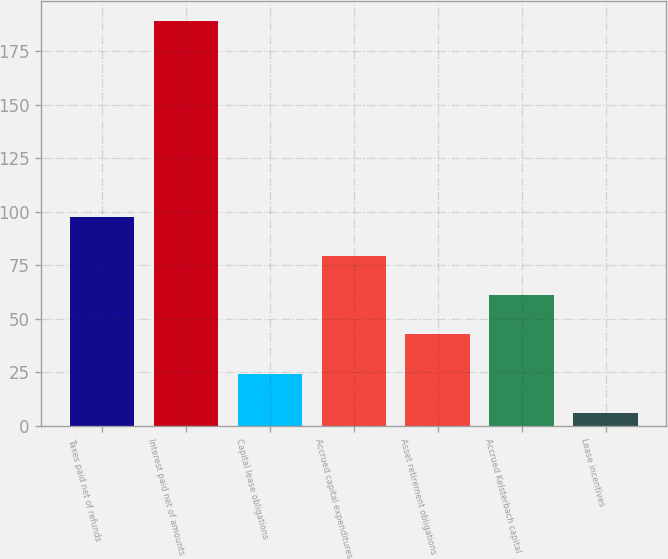<chart> <loc_0><loc_0><loc_500><loc_500><bar_chart><fcel>Taxes paid net of refunds<fcel>Interest paid net of amounts<fcel>Capital lease obligations<fcel>Accrued capital expenditures<fcel>Asset retirement obligations<fcel>Accrued Kelsterbach capital<fcel>Lease incentives<nl><fcel>97.5<fcel>189<fcel>24.3<fcel>79.2<fcel>42.6<fcel>60.9<fcel>6<nl></chart> 